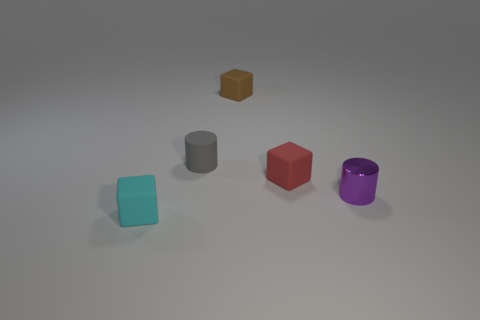Is there anything else that has the same material as the tiny purple thing?
Offer a very short reply. No. There is a matte block behind the cylinder to the left of the tiny cylinder in front of the red matte object; what is its size?
Your answer should be compact. Small. There is a red object that is the same size as the brown rubber cube; what shape is it?
Give a very brief answer. Cube. How many large things are either yellow metal cylinders or purple metal cylinders?
Ensure brevity in your answer.  0. Are there any small red blocks to the right of the small object that is in front of the small object that is on the right side of the red matte block?
Give a very brief answer. Yes. Are there any rubber things of the same size as the gray cylinder?
Give a very brief answer. Yes. There is a brown object that is the same size as the purple shiny object; what is its material?
Your answer should be compact. Rubber. Do the purple metallic cylinder and the matte object in front of the purple object have the same size?
Ensure brevity in your answer.  Yes. How many rubber objects are either cyan things or small gray things?
Give a very brief answer. 2. What number of other brown objects are the same shape as the small brown rubber object?
Offer a terse response. 0. 